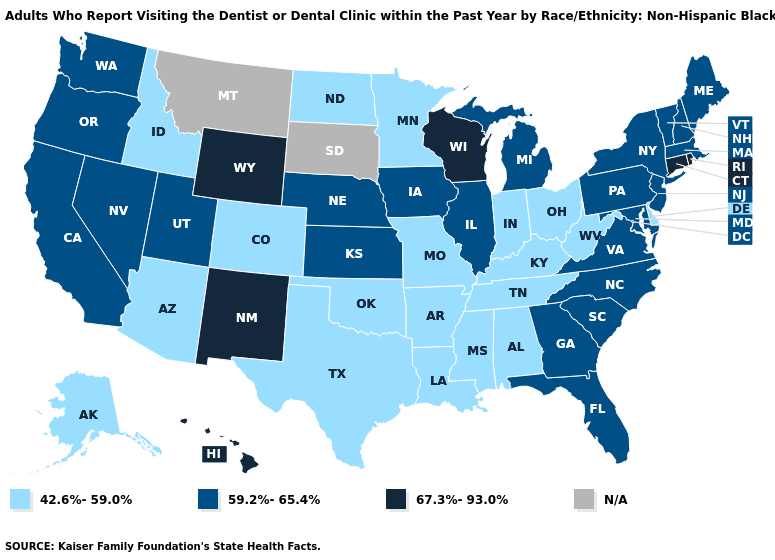Name the states that have a value in the range N/A?
Answer briefly. Montana, South Dakota. Which states hav the highest value in the West?
Answer briefly. Hawaii, New Mexico, Wyoming. What is the value of New Hampshire?
Give a very brief answer. 59.2%-65.4%. Does New Mexico have the highest value in the USA?
Write a very short answer. Yes. Does the map have missing data?
Keep it brief. Yes. What is the lowest value in the USA?
Write a very short answer. 42.6%-59.0%. Which states have the lowest value in the Northeast?
Short answer required. Maine, Massachusetts, New Hampshire, New Jersey, New York, Pennsylvania, Vermont. Which states hav the highest value in the West?
Write a very short answer. Hawaii, New Mexico, Wyoming. Among the states that border West Virginia , which have the highest value?
Give a very brief answer. Maryland, Pennsylvania, Virginia. What is the lowest value in states that border Indiana?
Write a very short answer. 42.6%-59.0%. What is the highest value in the USA?
Short answer required. 67.3%-93.0%. What is the value of Montana?
Short answer required. N/A. Name the states that have a value in the range 59.2%-65.4%?
Short answer required. California, Florida, Georgia, Illinois, Iowa, Kansas, Maine, Maryland, Massachusetts, Michigan, Nebraska, Nevada, New Hampshire, New Jersey, New York, North Carolina, Oregon, Pennsylvania, South Carolina, Utah, Vermont, Virginia, Washington. 